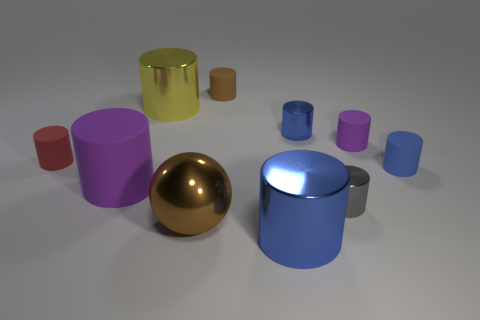Subtract all cyan balls. How many blue cylinders are left? 3 Subtract all red cylinders. How many cylinders are left? 8 Subtract all red rubber cylinders. How many cylinders are left? 8 Subtract 3 cylinders. How many cylinders are left? 6 Subtract all yellow cylinders. Subtract all cyan spheres. How many cylinders are left? 8 Subtract all spheres. How many objects are left? 9 Add 7 small brown things. How many small brown things exist? 8 Subtract 0 purple spheres. How many objects are left? 10 Subtract all large brown spheres. Subtract all small rubber things. How many objects are left? 5 Add 1 gray metallic objects. How many gray metallic objects are left? 2 